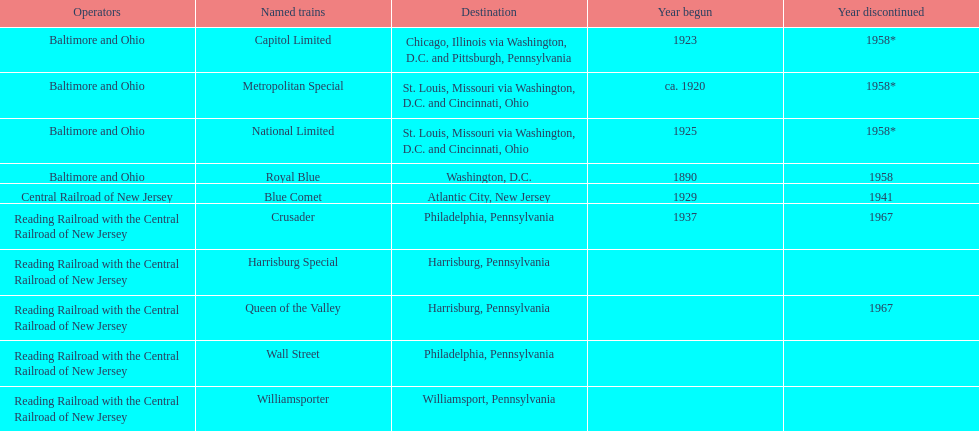How many trains were discontinued in 1958? 4. 